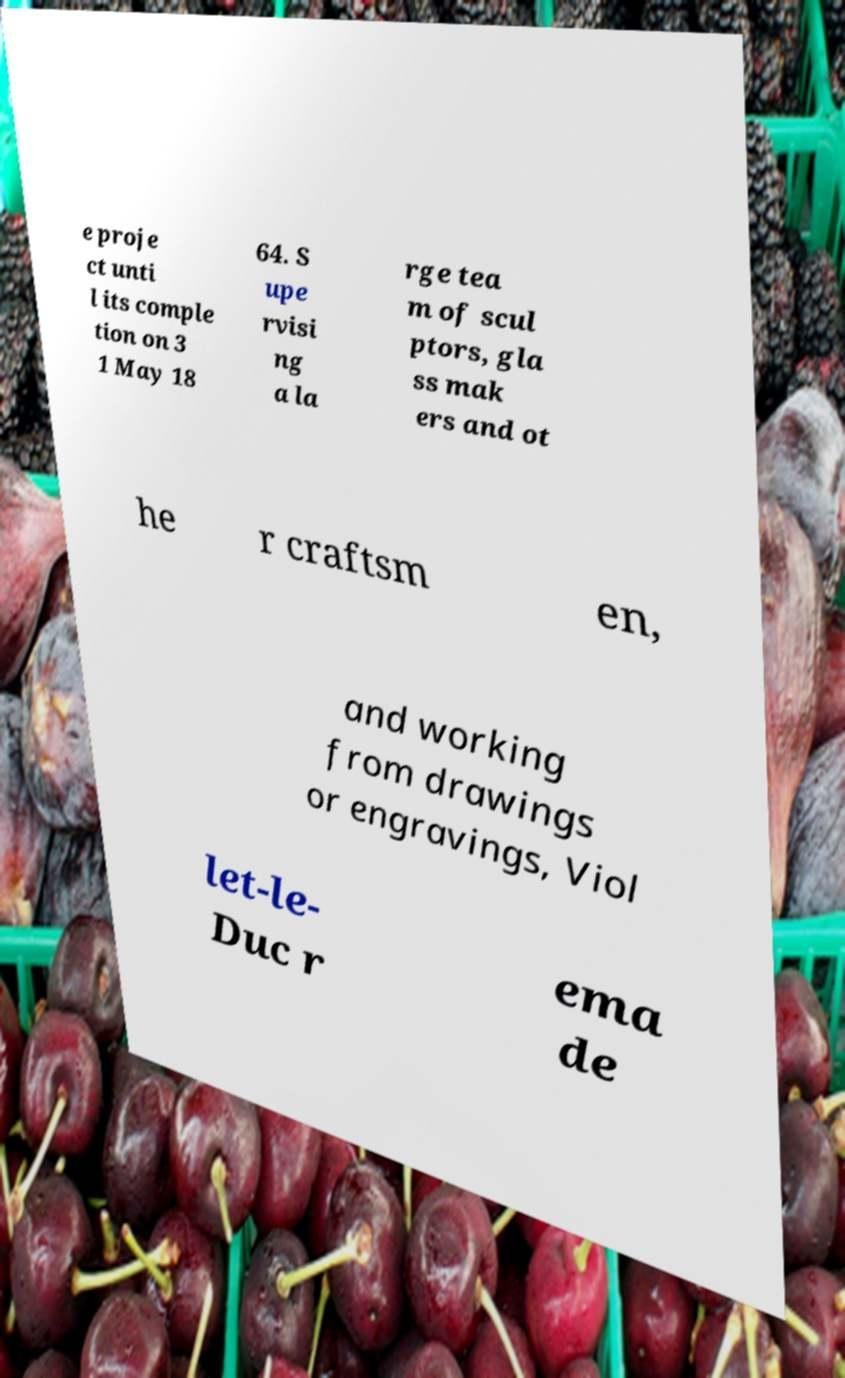Please identify and transcribe the text found in this image. e proje ct unti l its comple tion on 3 1 May 18 64. S upe rvisi ng a la rge tea m of scul ptors, gla ss mak ers and ot he r craftsm en, and working from drawings or engravings, Viol let-le- Duc r ema de 